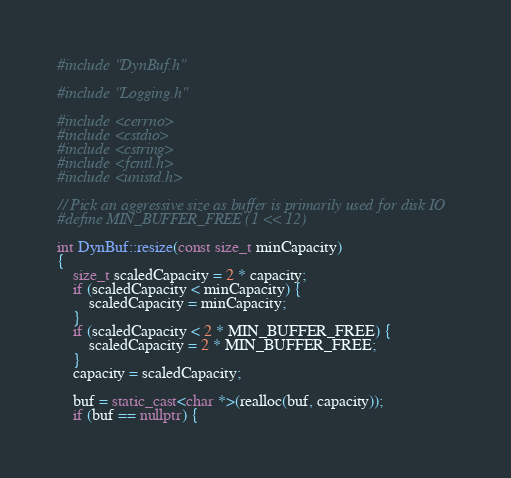<code> <loc_0><loc_0><loc_500><loc_500><_C++_>#include "DynBuf.h"

#include "Logging.h"

#include <cerrno>
#include <cstdio>
#include <cstring>
#include <fcntl.h>
#include <unistd.h>

// Pick an aggressive size as buffer is primarily used for disk IO
#define MIN_BUFFER_FREE (1 << 12)

int DynBuf::resize(const size_t minCapacity)
{
    size_t scaledCapacity = 2 * capacity;
    if (scaledCapacity < minCapacity) {
        scaledCapacity = minCapacity;
    }
    if (scaledCapacity < 2 * MIN_BUFFER_FREE) {
        scaledCapacity = 2 * MIN_BUFFER_FREE;
    }
    capacity = scaledCapacity;

    buf = static_cast<char *>(realloc(buf, capacity));
    if (buf == nullptr) {</code> 